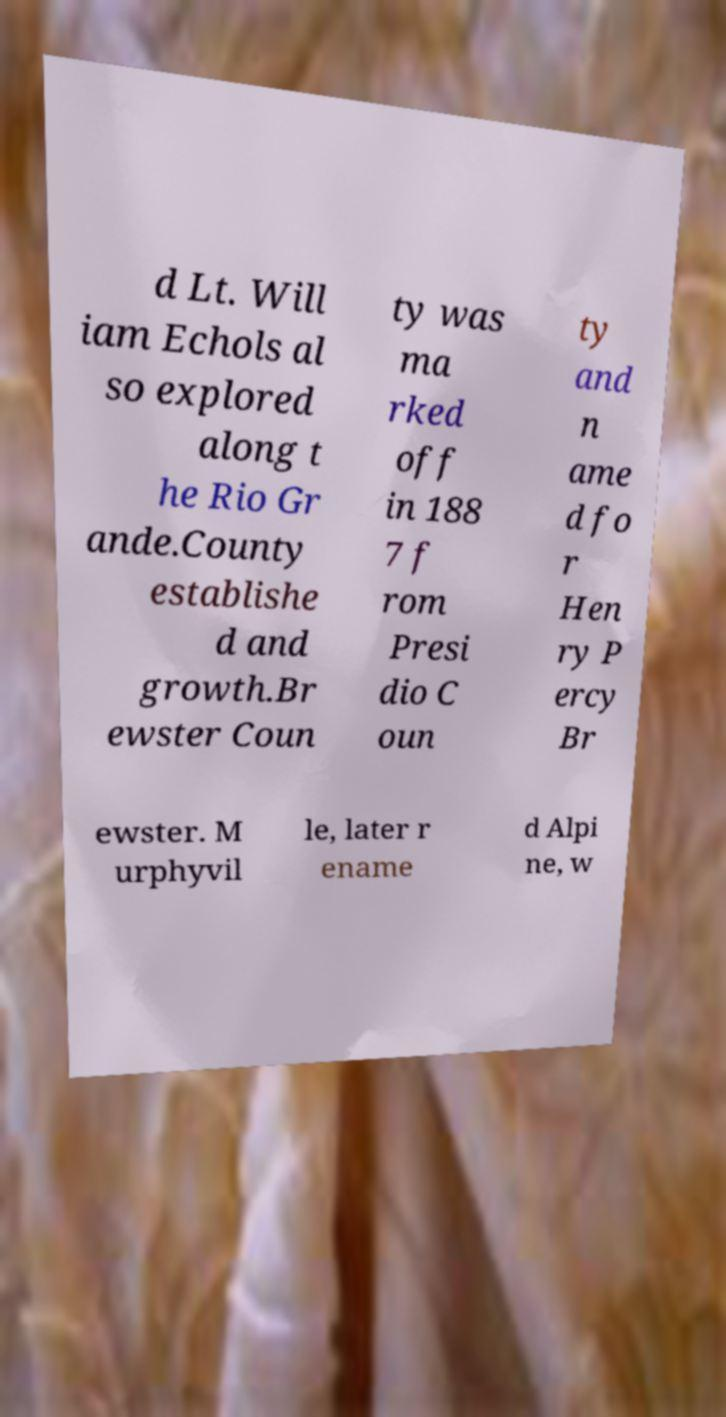Please read and relay the text visible in this image. What does it say? d Lt. Will iam Echols al so explored along t he Rio Gr ande.County establishe d and growth.Br ewster Coun ty was ma rked off in 188 7 f rom Presi dio C oun ty and n ame d fo r Hen ry P ercy Br ewster. M urphyvil le, later r ename d Alpi ne, w 